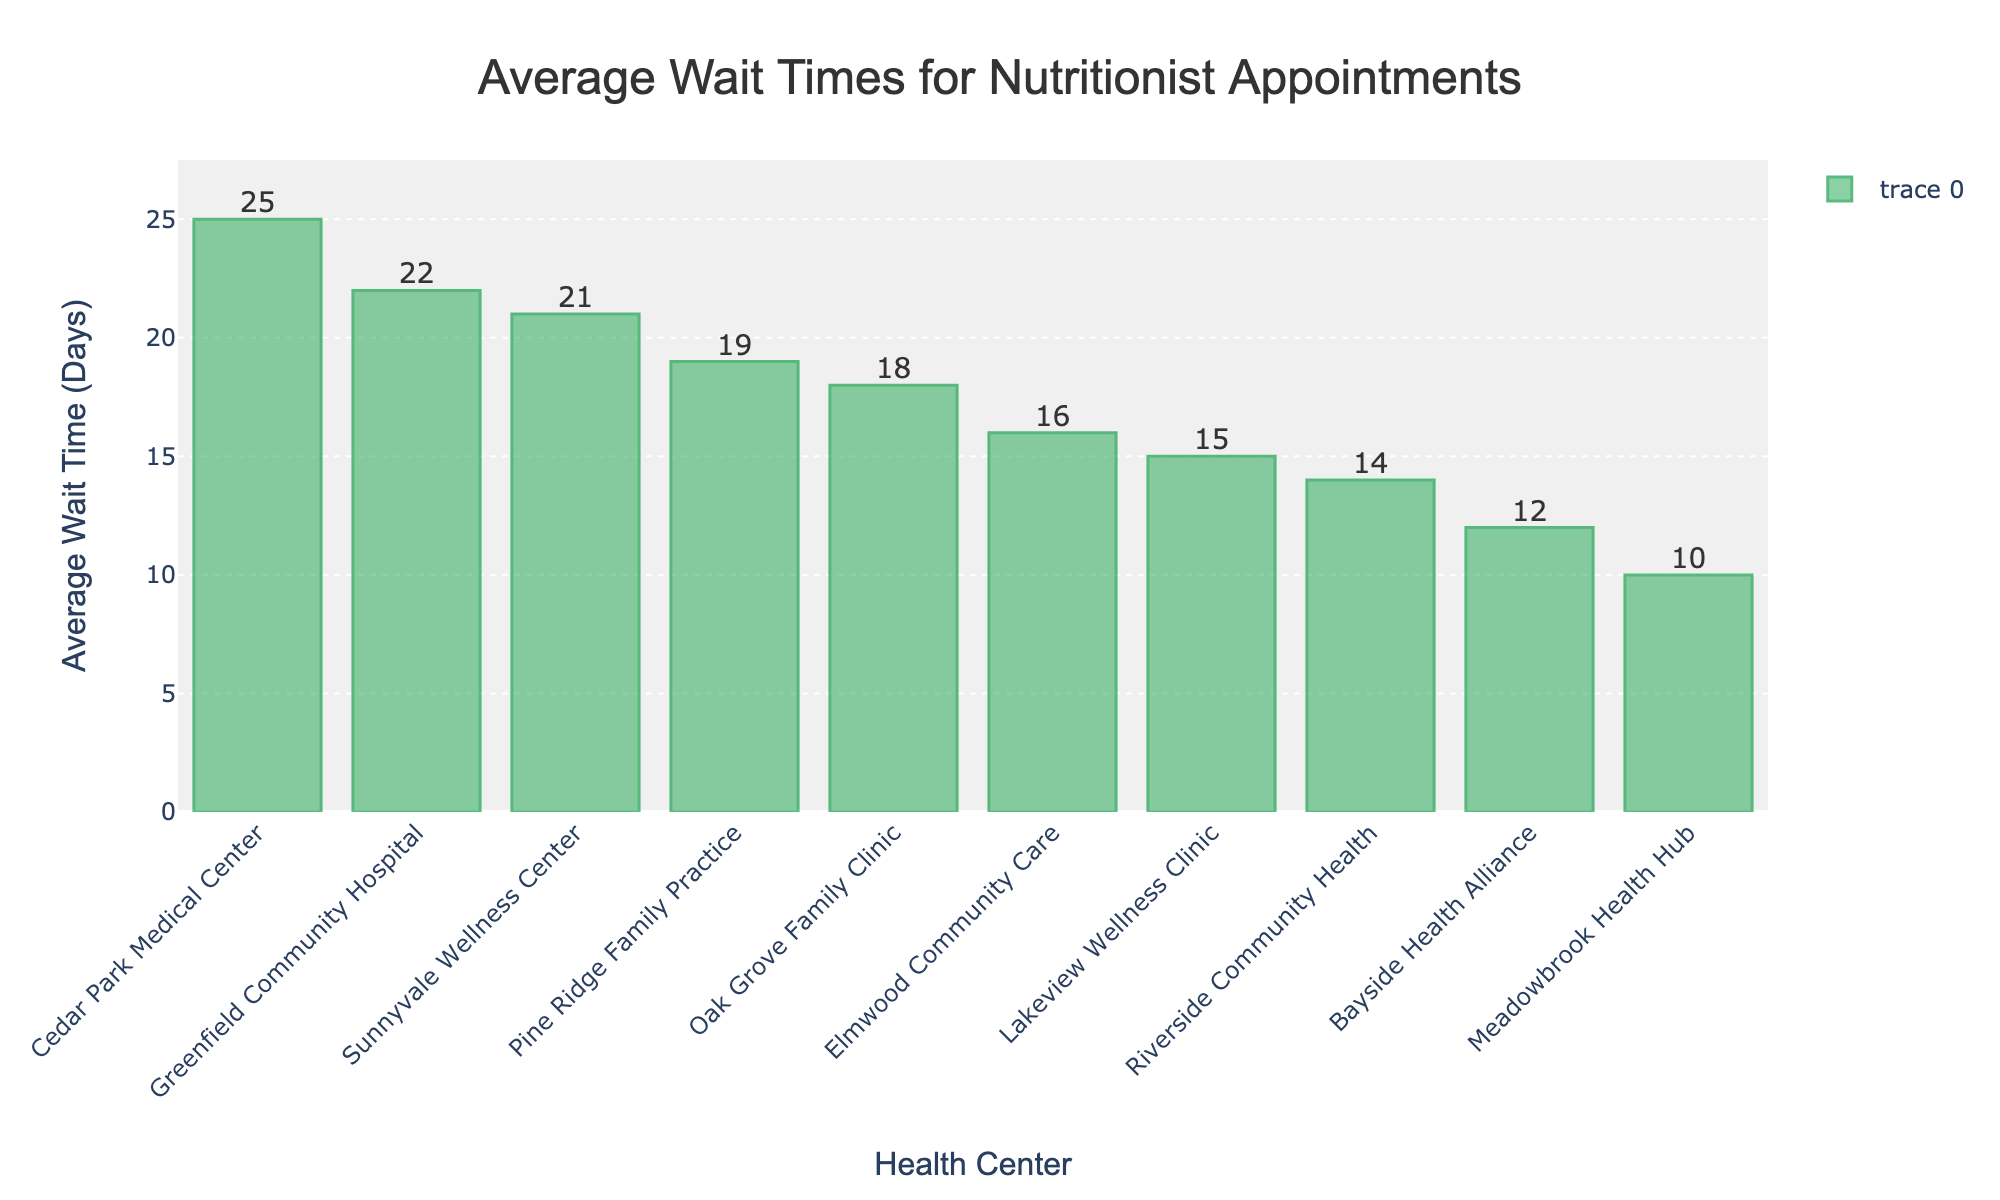Which health center has the shortest average wait time for nutritionist appointments? The bar corresponding to Meadowbrook Health Hub is the shortest compared to others, indicating that it has the shortest average wait time of 10 days.
Answer: Meadowbrook Health Hub Which health center has the longest average wait time for nutritionist appointments? The bar corresponding to Cedar Park Medical Center is the tallest compared to others, indicating that it has the longest average wait time of 25 days.
Answer: Cedar Park Medical Center How much longer is the average wait time at Cedar Park Medical Center compared to Meadowbrook Health Hub? Cedar Park Medical Center has an average wait time of 25 days, while Meadowbrook Health Hub has an average wait time of 10 days. The difference is 25 - 10 = 15 days.
Answer: 15 days What is the range of average wait times across all health centers? The shortest wait time is 10 days (Meadowbrook Health Hub) and the longest is 25 days (Cedar Park Medical Center). The range is 25 - 10 = 15 days.
Answer: 15 days Which health centers have an average wait time greater than 20 days? By examining the heights of the bars, the health centers with average wait times greater than 20 days are Sunnyvale Wellness Center, Cedar Park Medical Center, and Greenfield Community Hospital.
Answer: Sunnyvale Wellness Center, Cedar Park Medical Center, Greenfield Community Hospital What is the average wait time for all health centers combined? Add all the average wait times and divide by the number of health centers: (14 + 21 + 18 + 10 + 25 + 16 + 12 + 19 + 15 + 22) / 10 = 172 / 10 = 17.2 days.
Answer: 17.2 days How does Bayside Health Alliance's average wait time compare to Elmwood Community Care's? Bayside Health Alliance has a wait time of 12 days, while Elmwood Community Care has 16 days. Bayside Health Alliance's wait time is 16 - 12 = 4 days shorter.
Answer: 4 days shorter If we group the health centers into two categories with average wait times less than 15 days and those 15 days or more, how many health centers fall into each category? Health centers with less than 15 days: Riverside Community Health, Meadowbrook Health Hub, Bayside Health Alliance (3). Health centers with 15 days or more: Sunnyvale Wellness Center, Oak Grove Family Clinic, Cedar Park Medical Center, Elmwood Community Care, Pine Ridge Family Practice, Lakeview Wellness Clinic, Greenfield Community Hospital (7).
Answer: Less than 15 days: 3, 15 days or more: 7 What's the sum of the average wait times for Riverside Community Health and Greenfield Community Hospital? Sum the average wait times for both: 14 (Riverside Community Health) + 22 (Greenfield Community Hospital) = 36 days.
Answer: 36 days 